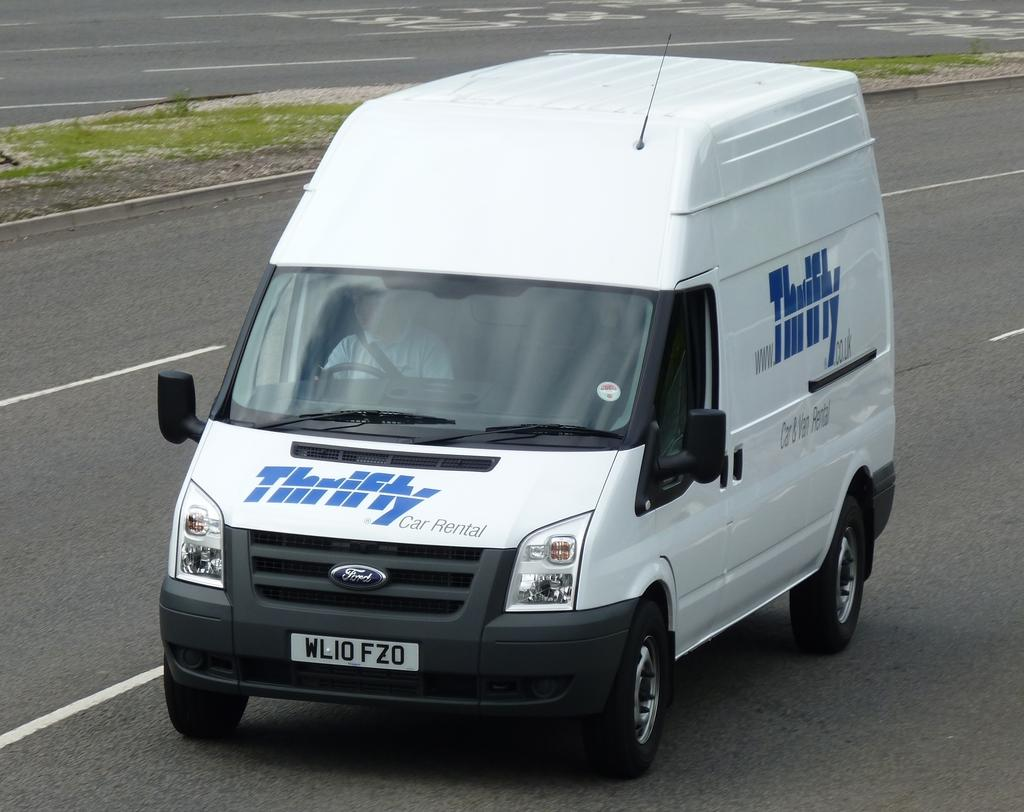<image>
Present a compact description of the photo's key features. White van with blue words that says Thrifty. 